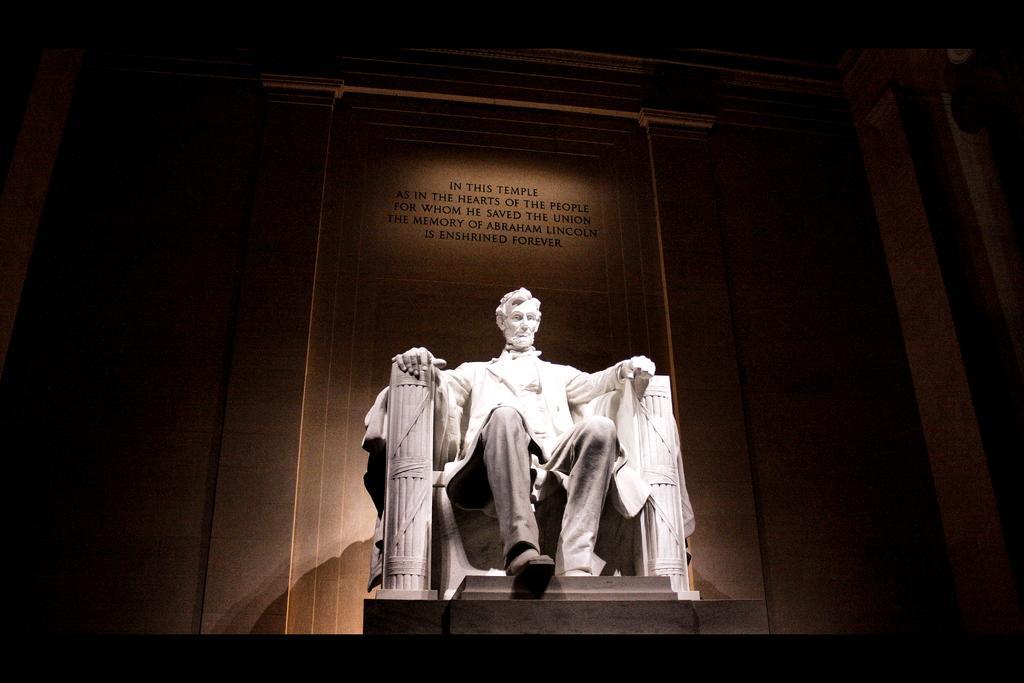Could you give a brief overview of what you see in this image? In the picture there is a sculpture of a person in a sitting position and behind the sculpture there is some quotation mentioned on the wall. 